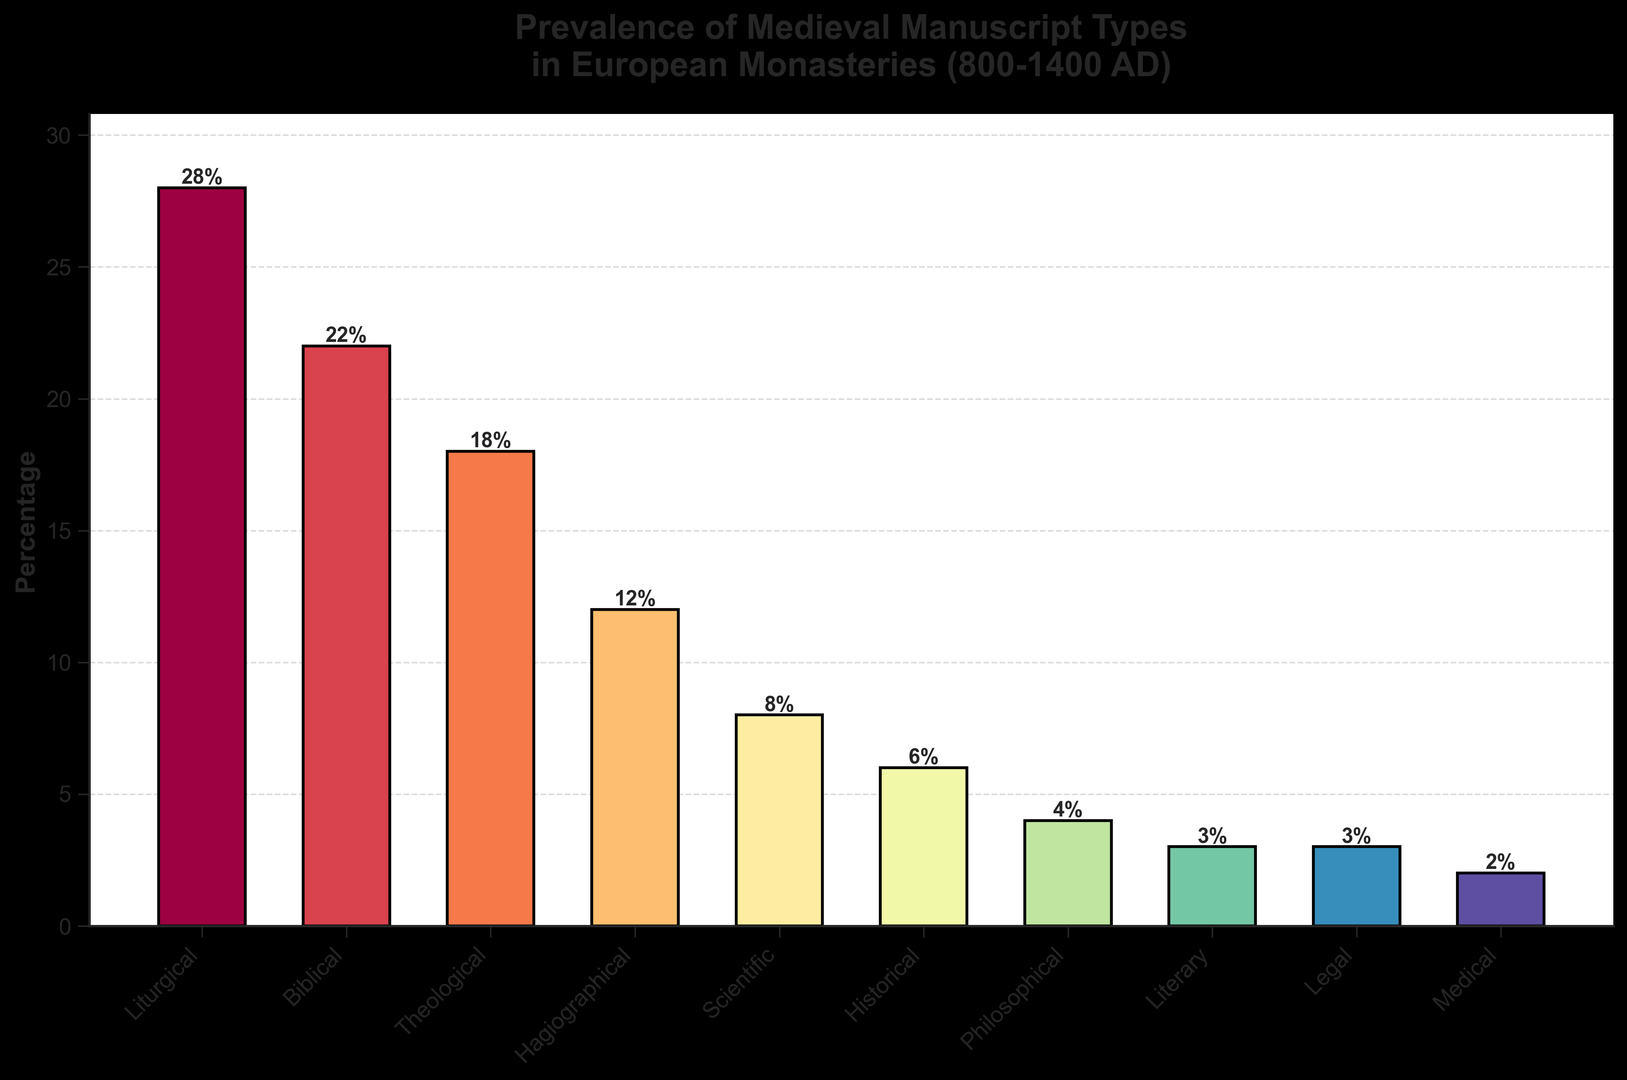Which manuscript type is the most prevalent? The most prevalent manuscript type is the one with the highest percentage. Based on the bar chart, Liturgical manuscripts have the highest percentage at 28%.
Answer: Liturgical What is the combined percentage of Liturgical and Biblical manuscripts? To find the combined percentage of two manuscript types, add their individual percentages. The percentage for Liturgical is 28%, and for Biblical is 22%. So, 28 + 22 = 50%.
Answer: 50% Which type of manuscript has a lower percentage: Historical or Medical? Compare the percentages of Historical and Medical manuscripts. Historical manuscripts have 6%, while Medical manuscripts have 2%. Thus, Medical manuscripts have a lower percentage.
Answer: Medical What proportion of the total do Scientific and Historical manuscripts constitute together? Sum the percentages of Scientific and Historical manuscripts. Scientific manuscripts have 8%, and Historical manuscripts have 6%. So, 8 + 6 = 14%.
Answer: 14% How much more prevalent are Religious categories (Liturgical, Biblical, Theological) compared to non-Religious categories (Scientific, Historical, Philosophical, Literary, Legal, Medical)? First, sum the percentages of the religious categories: Liturgical (28%), Biblical (22%), and Theological (18%). This sums to 28 + 22 + 18 = 68%. Then, sum the percentages of non-religious categories: Scientific (8%), Historical (6%), Philosophical (4%), Literary (3%), Legal (3%), Medical (2%). This sums to 8 + 6 + 4 + 3 + 3 + 2 = 26%. Subtract the two sums: 68% - 26% = 42%.
Answer: 42% Which type of manuscript is exactly 1% more prevalent than Philosophical manuscripts? To determine which manuscript type is 1% more prevalent than Philosophical manuscripts, identify the percentage of Philosophical manuscripts (4%) and add 1% to it (4 + 1 = 5%). Look for the type with this percentage, but since no specific type matches exactly 5%, there is no direct match.
Answer: None What is the average percentage for all manuscript types? Sum all percentages and divide by the number of types. The sum is 28 + 22 + 18 + 12 + 8 + 6 + 4 + 3 + 3 + 2 = 106. There are 10 types, so the average is 106 / 10 = 10.6%.
Answer: 10.6% Which has a higher prevalence, Hagiographical or Scientific manuscripts? Compare the percentages of Hagiographical (12%) and Scientific (8%) manuscripts. Hagiographical manuscripts have a higher percentage.
Answer: Hagiographical What percentage is represented by the combined categories of Hagiographical, Literary, and Legal manuscripts? Sum the percentages of Hagiographical (12%), Literary (3%), and Legal (3%) manuscripts. 12 + 3 + 3 = 18%.
Answer: 18% What is the difference in percentage between Theological and Philosophical manuscripts? Subtract the percentage of Philosophical manuscripts (4%) from Theological manuscripts (18%). So, 18 - 4 = 14%.
Answer: 14% 